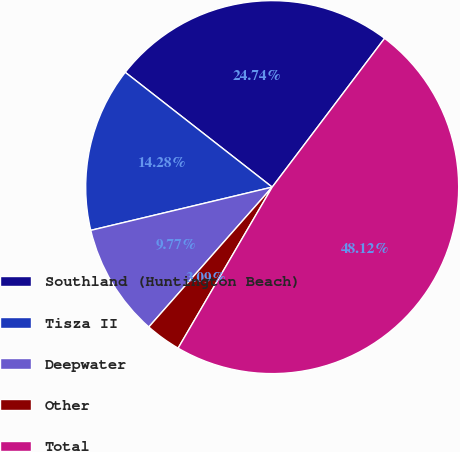Convert chart to OTSL. <chart><loc_0><loc_0><loc_500><loc_500><pie_chart><fcel>Southland (Huntington Beach)<fcel>Tisza II<fcel>Deepwater<fcel>Other<fcel>Total<nl><fcel>24.74%<fcel>14.28%<fcel>9.77%<fcel>3.09%<fcel>48.12%<nl></chart> 